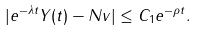<formula> <loc_0><loc_0><loc_500><loc_500>| e ^ { - \lambda t } Y ( t ) - N v | \leq C _ { 1 } e ^ { - \rho t } .</formula> 